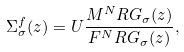Convert formula to latex. <formula><loc_0><loc_0><loc_500><loc_500>\Sigma ^ { f } _ { \sigma } ( z ) = U \frac { M ^ { N } R G _ { \sigma } ( z ) } { F ^ { N } R G _ { \sigma } ( z ) } ,</formula> 